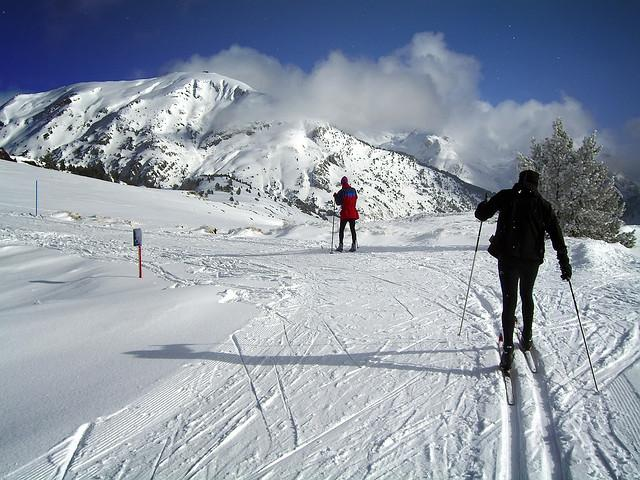What is misting up from the mountain? clouds 